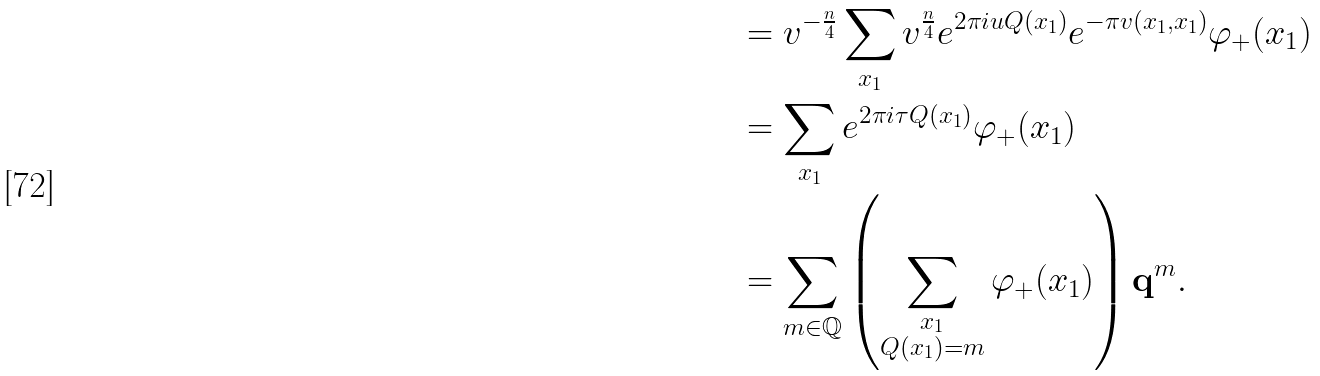<formula> <loc_0><loc_0><loc_500><loc_500>& = v ^ { - \frac { n } { 4 } } \sum _ { x _ { 1 } } v ^ { \frac { n } { 4 } } e ^ { 2 \pi i u Q ( x _ { 1 } ) } e ^ { - \pi v ( x _ { 1 } , x _ { 1 } ) } \varphi _ { + } ( x _ { 1 } ) \\ & = \sum _ { x _ { 1 } } e ^ { 2 \pi i \tau Q ( x _ { 1 } ) } \varphi _ { + } ( x _ { 1 } ) \\ & = \sum _ { m \in \mathbb { Q } } \left ( \sum _ { \substack { x _ { 1 } \\ Q ( x _ { 1 } ) = m } } \varphi _ { + } ( x _ { 1 } ) \right ) \mathbf q ^ { m } .</formula> 